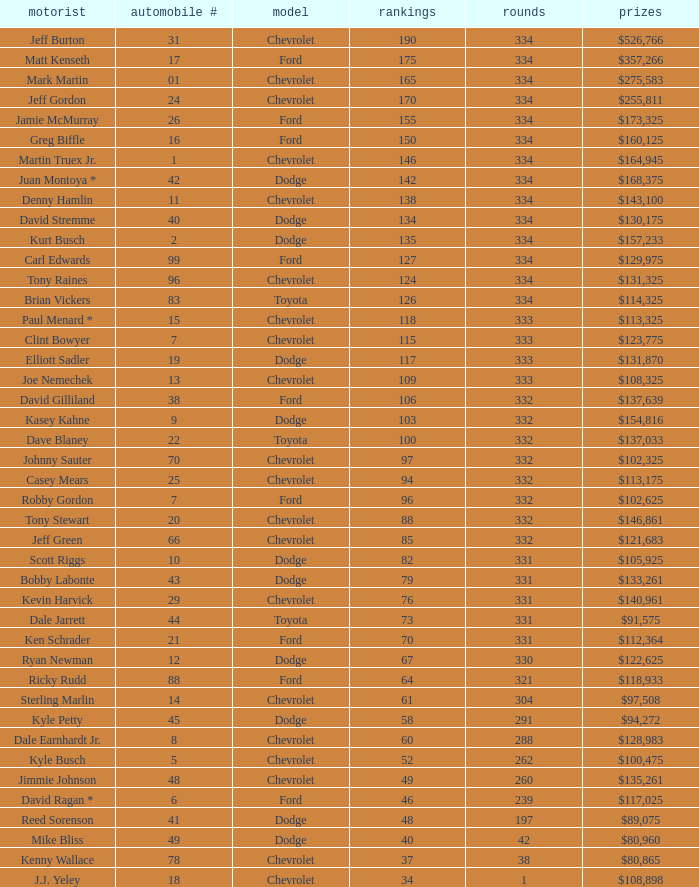How many total laps did the Chevrolet that won $97,508 make? 1.0. 